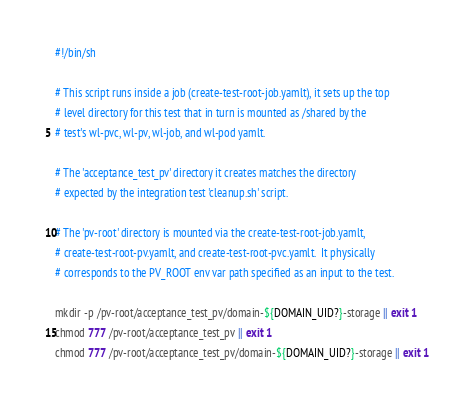Convert code to text. <code><loc_0><loc_0><loc_500><loc_500><_Bash_>#!/bin/sh

# This script runs inside a job (create-test-root-job.yamlt), it sets up the top
# level directory for this test that in turn is mounted as /shared by the 
# test's wl-pvc, wl-pv, wl-job, and wl-pod yamlt.

# The 'acceptance_test_pv' directory it creates matches the directory 
# expected by the integration test 'cleanup.sh' script.

# The 'pv-root' directory is mounted via the create-test-root-job.yamlt, 
# create-test-root-pv.yamlt, and create-test-root-pvc.yamlt.  It physically
# corresponds to the PV_ROOT env var path specified as an input to the test.

mkdir -p /pv-root/acceptance_test_pv/domain-${DOMAIN_UID?}-storage || exit 1
chmod 777 /pv-root/acceptance_test_pv || exit 1
chmod 777 /pv-root/acceptance_test_pv/domain-${DOMAIN_UID?}-storage || exit 1
</code> 